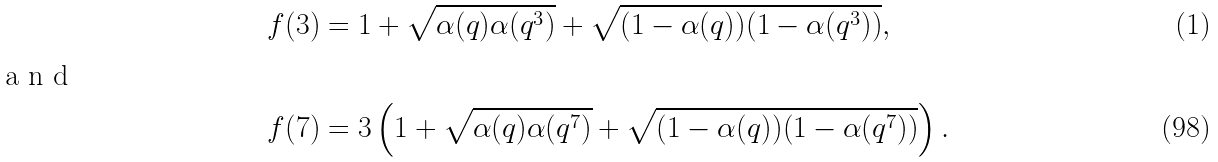Convert formula to latex. <formula><loc_0><loc_0><loc_500><loc_500>f ( 3 ) & = 1 + \sqrt { \alpha ( q ) \alpha ( q ^ { 3 } ) } + \sqrt { ( 1 - \alpha ( q ) ) ( 1 - \alpha ( q ^ { 3 } ) ) } , \intertext { a n d } f ( 7 ) & = 3 \left ( 1 + \sqrt { \alpha ( q ) \alpha ( q ^ { 7 } ) } + \sqrt { ( 1 - \alpha ( q ) ) ( 1 - \alpha ( q ^ { 7 } ) ) } \right ) .</formula> 